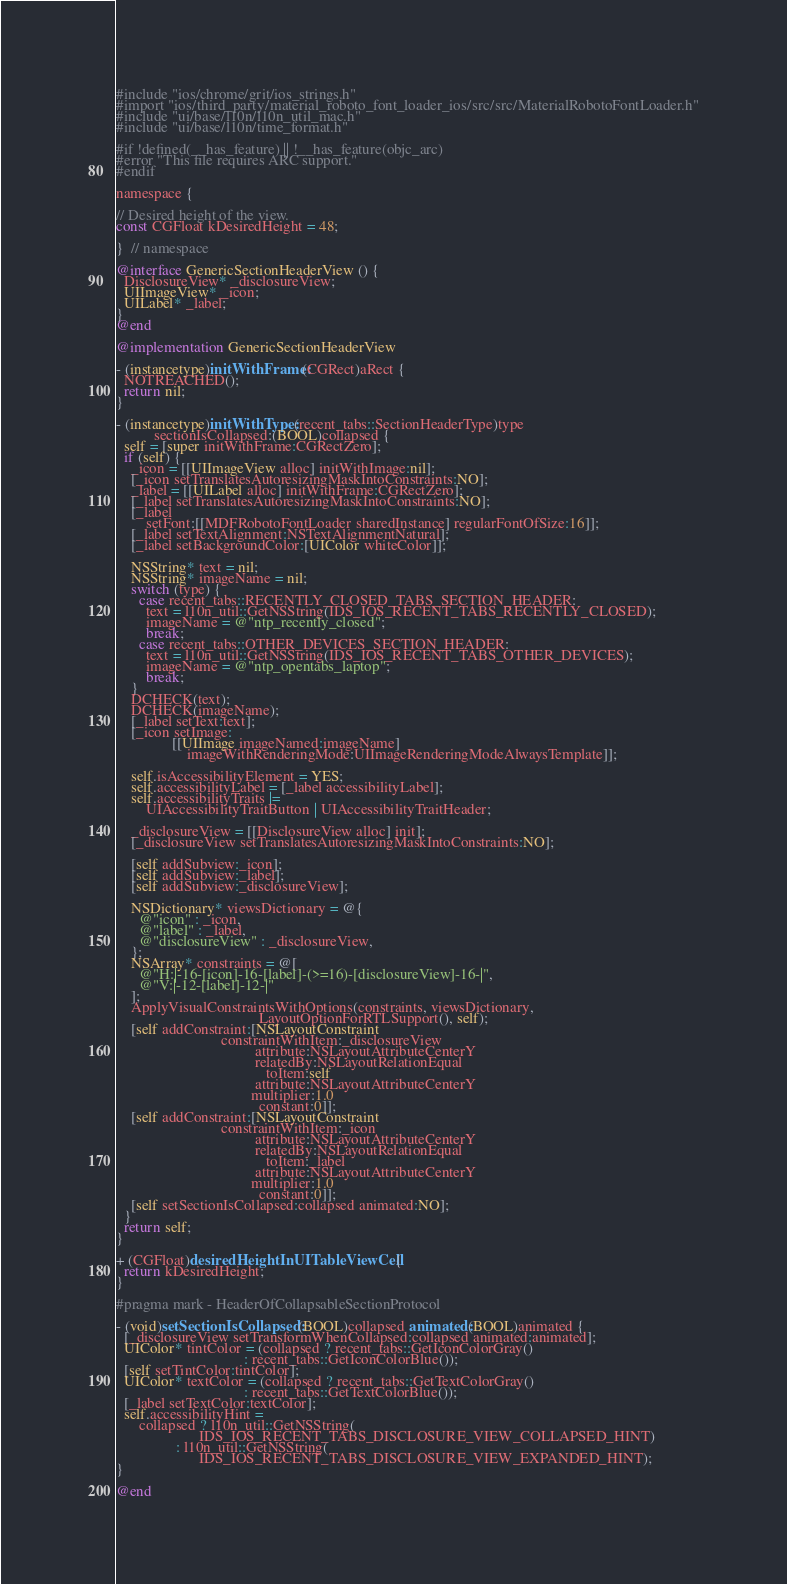Convert code to text. <code><loc_0><loc_0><loc_500><loc_500><_ObjectiveC_>#include "ios/chrome/grit/ios_strings.h"
#import "ios/third_party/material_roboto_font_loader_ios/src/src/MaterialRobotoFontLoader.h"
#include "ui/base/l10n/l10n_util_mac.h"
#include "ui/base/l10n/time_format.h"

#if !defined(__has_feature) || !__has_feature(objc_arc)
#error "This file requires ARC support."
#endif

namespace {

// Desired height of the view.
const CGFloat kDesiredHeight = 48;

}  // namespace

@interface GenericSectionHeaderView () {
  DisclosureView* _disclosureView;
  UIImageView* _icon;
  UILabel* _label;
}
@end

@implementation GenericSectionHeaderView

- (instancetype)initWithFrame:(CGRect)aRect {
  NOTREACHED();
  return nil;
}

- (instancetype)initWithType:(recent_tabs::SectionHeaderType)type
          sectionIsCollapsed:(BOOL)collapsed {
  self = [super initWithFrame:CGRectZero];
  if (self) {
    _icon = [[UIImageView alloc] initWithImage:nil];
    [_icon setTranslatesAutoresizingMaskIntoConstraints:NO];
    _label = [[UILabel alloc] initWithFrame:CGRectZero];
    [_label setTranslatesAutoresizingMaskIntoConstraints:NO];
    [_label
        setFont:[[MDFRobotoFontLoader sharedInstance] regularFontOfSize:16]];
    [_label setTextAlignment:NSTextAlignmentNatural];
    [_label setBackgroundColor:[UIColor whiteColor]];

    NSString* text = nil;
    NSString* imageName = nil;
    switch (type) {
      case recent_tabs::RECENTLY_CLOSED_TABS_SECTION_HEADER:
        text = l10n_util::GetNSString(IDS_IOS_RECENT_TABS_RECENTLY_CLOSED);
        imageName = @"ntp_recently_closed";
        break;
      case recent_tabs::OTHER_DEVICES_SECTION_HEADER:
        text = l10n_util::GetNSString(IDS_IOS_RECENT_TABS_OTHER_DEVICES);
        imageName = @"ntp_opentabs_laptop";
        break;
    }
    DCHECK(text);
    DCHECK(imageName);
    [_label setText:text];
    [_icon setImage:
               [[UIImage imageNamed:imageName]
                   imageWithRenderingMode:UIImageRenderingModeAlwaysTemplate]];

    self.isAccessibilityElement = YES;
    self.accessibilityLabel = [_label accessibilityLabel];
    self.accessibilityTraits |=
        UIAccessibilityTraitButton | UIAccessibilityTraitHeader;

    _disclosureView = [[DisclosureView alloc] init];
    [_disclosureView setTranslatesAutoresizingMaskIntoConstraints:NO];

    [self addSubview:_icon];
    [self addSubview:_label];
    [self addSubview:_disclosureView];

    NSDictionary* viewsDictionary = @{
      @"icon" : _icon,
      @"label" : _label,
      @"disclosureView" : _disclosureView,
    };
    NSArray* constraints = @[
      @"H:|-16-[icon]-16-[label]-(>=16)-[disclosureView]-16-|",
      @"V:|-12-[label]-12-|"
    ];
    ApplyVisualConstraintsWithOptions(constraints, viewsDictionary,
                                      LayoutOptionForRTLSupport(), self);
    [self addConstraint:[NSLayoutConstraint
                            constraintWithItem:_disclosureView
                                     attribute:NSLayoutAttributeCenterY
                                     relatedBy:NSLayoutRelationEqual
                                        toItem:self
                                     attribute:NSLayoutAttributeCenterY
                                    multiplier:1.0
                                      constant:0]];
    [self addConstraint:[NSLayoutConstraint
                            constraintWithItem:_icon
                                     attribute:NSLayoutAttributeCenterY
                                     relatedBy:NSLayoutRelationEqual
                                        toItem:_label
                                     attribute:NSLayoutAttributeCenterY
                                    multiplier:1.0
                                      constant:0]];
    [self setSectionIsCollapsed:collapsed animated:NO];
  }
  return self;
}

+ (CGFloat)desiredHeightInUITableViewCell {
  return kDesiredHeight;
}

#pragma mark - HeaderOfCollapsableSectionProtocol

- (void)setSectionIsCollapsed:(BOOL)collapsed animated:(BOOL)animated {
  [_disclosureView setTransformWhenCollapsed:collapsed animated:animated];
  UIColor* tintColor = (collapsed ? recent_tabs::GetIconColorGray()
                                  : recent_tabs::GetIconColorBlue());
  [self setTintColor:tintColor];
  UIColor* textColor = (collapsed ? recent_tabs::GetTextColorGray()
                                  : recent_tabs::GetTextColorBlue());
  [_label setTextColor:textColor];
  self.accessibilityHint =
      collapsed ? l10n_util::GetNSString(
                      IDS_IOS_RECENT_TABS_DISCLOSURE_VIEW_COLLAPSED_HINT)
                : l10n_util::GetNSString(
                      IDS_IOS_RECENT_TABS_DISCLOSURE_VIEW_EXPANDED_HINT);
}

@end
</code> 